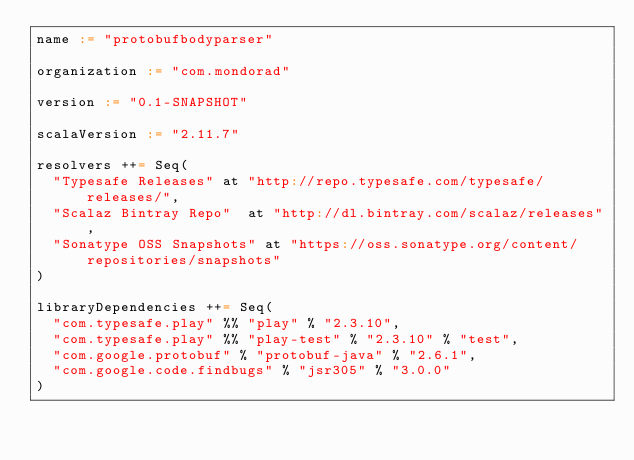<code> <loc_0><loc_0><loc_500><loc_500><_Scala_>name := "protobufbodyparser"

organization := "com.mondorad"

version := "0.1-SNAPSHOT"

scalaVersion := "2.11.7"

resolvers ++= Seq(
  "Typesafe Releases" at "http://repo.typesafe.com/typesafe/releases/",
  "Scalaz Bintray Repo"  at "http://dl.bintray.com/scalaz/releases",
  "Sonatype OSS Snapshots" at "https://oss.sonatype.org/content/repositories/snapshots"
)

libraryDependencies ++= Seq(
  "com.typesafe.play" %% "play" % "2.3.10",
  "com.typesafe.play" %% "play-test" % "2.3.10" % "test",
  "com.google.protobuf" % "protobuf-java" % "2.6.1",
  "com.google.code.findbugs" % "jsr305" % "3.0.0"
)


</code> 